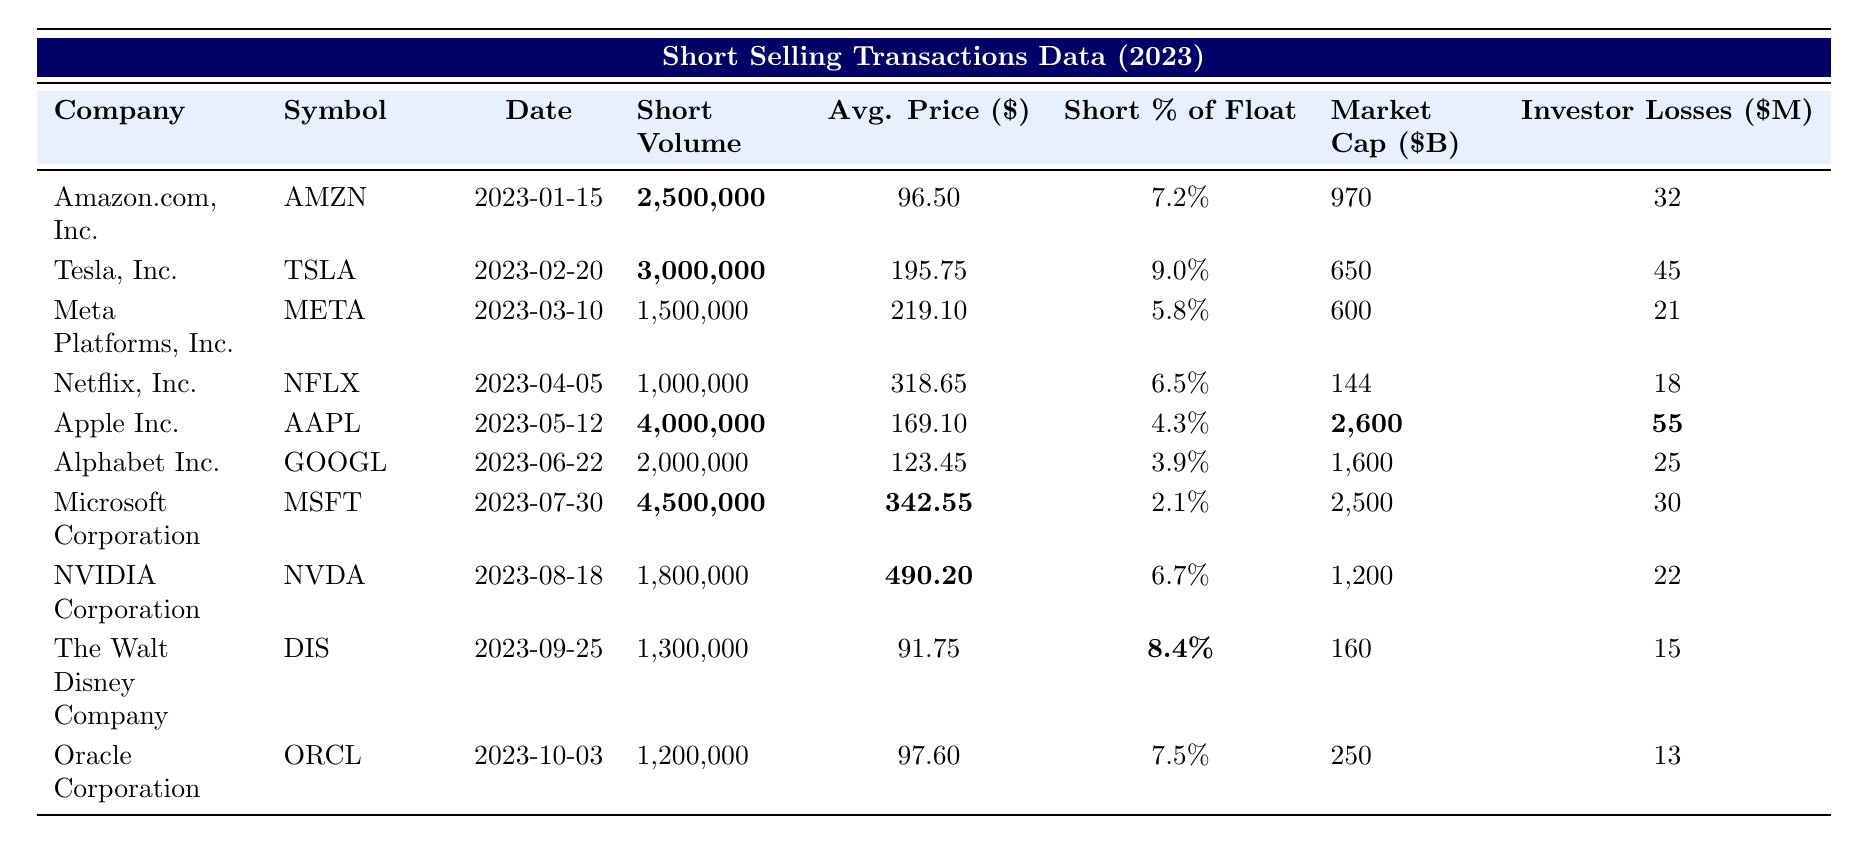What was the short volume for Tesla, Inc.? Looking at the row for Tesla, Inc. (TSLA), the table shows the short volume as 3,000,000.
Answer: 3,000,000 Which company had the highest investor losses? The investor losses for each company are compared. Apple Inc. (AAPL) has investor losses of 55 million, which is higher than any other company listed.
Answer: Apple Inc What was the average price of shares shorted for Microsoft Corporation? Referring to the row for Microsoft Corporation (MSFT), the average price is explicitly mentioned as 342.55.
Answer: 342.55 How many companies had a short percentage of float above 7%? The short percentages for each company are examined, and only Amazon (7.2%), Tesla (9.0%), and Oracle (7.5%) exceed 7%. This totals three companies.
Answer: 3 What is the total short volume for all companies listed in the table? The short volumes for each company are summed as follows: 2,500,000 + 3,000,000 + 1,500,000 + 1,000,000 + 4,000,000 + 2,000,000 + 4,500,000 + 1,800,000 + 1,300,000 + 1,200,000 = 23,800,000.
Answer: 23,800,000 Did any of the companies have investor losses below 20 million? Looking at the investor losses, both Netflix (NFLX) with 18 million and Oracle (ORCL) with 13 million have losses below 20 million, which confirms the statement is true.
Answer: Yes What market cap has a higher average price than its short percentage of float? The market caps and average prices should be checked: Apple Inc. has an average price of 169.10 and a short percentage of float of 4.3%, which is higher in both aspects. Microsoft also fits as its average price is 342.55 with a short % of 2.1%. Thus, both have a higher average price than short percentage.
Answer: Apple Inc. and Microsoft Corporation Which company had the second-highest short volume and what was it? Listing the short volumes, Tesla has the highest at 3,000,000, while Apple comes next with 4,000,000. So, Apple has the second-highest volume.
Answer: 4,000,000 Calculate the difference in investor losses between Tesla, Inc. and Meta Platforms, Inc. The investor losses are subtracted: Tesla has 45 million and Meta has 21 million, so 45 - 21 = 24 million difference.
Answer: 24 million What percentage of the float was shorted for the Walt Disney Company? Referring to the row for The Walt Disney Company (DIS), the short percentage of float is clearly indicated as 8.4%.
Answer: 8.4% 